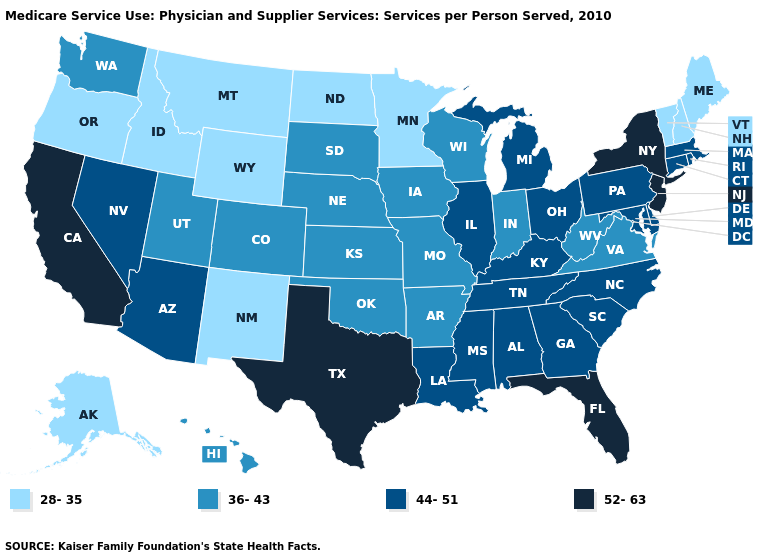What is the lowest value in the USA?
Answer briefly. 28-35. What is the lowest value in the USA?
Give a very brief answer. 28-35. Does Montana have the lowest value in the USA?
Quick response, please. Yes. What is the value of Mississippi?
Quick response, please. 44-51. What is the value of Michigan?
Concise answer only. 44-51. Does Delaware have a higher value than Arizona?
Give a very brief answer. No. What is the highest value in the USA?
Concise answer only. 52-63. What is the value of Rhode Island?
Concise answer only. 44-51. Name the states that have a value in the range 36-43?
Concise answer only. Arkansas, Colorado, Hawaii, Indiana, Iowa, Kansas, Missouri, Nebraska, Oklahoma, South Dakota, Utah, Virginia, Washington, West Virginia, Wisconsin. Among the states that border Illinois , which have the lowest value?
Be succinct. Indiana, Iowa, Missouri, Wisconsin. Name the states that have a value in the range 52-63?
Give a very brief answer. California, Florida, New Jersey, New York, Texas. What is the value of Ohio?
Quick response, please. 44-51. Name the states that have a value in the range 52-63?
Short answer required. California, Florida, New Jersey, New York, Texas. What is the lowest value in the USA?
Quick response, please. 28-35. Which states have the highest value in the USA?
Short answer required. California, Florida, New Jersey, New York, Texas. 